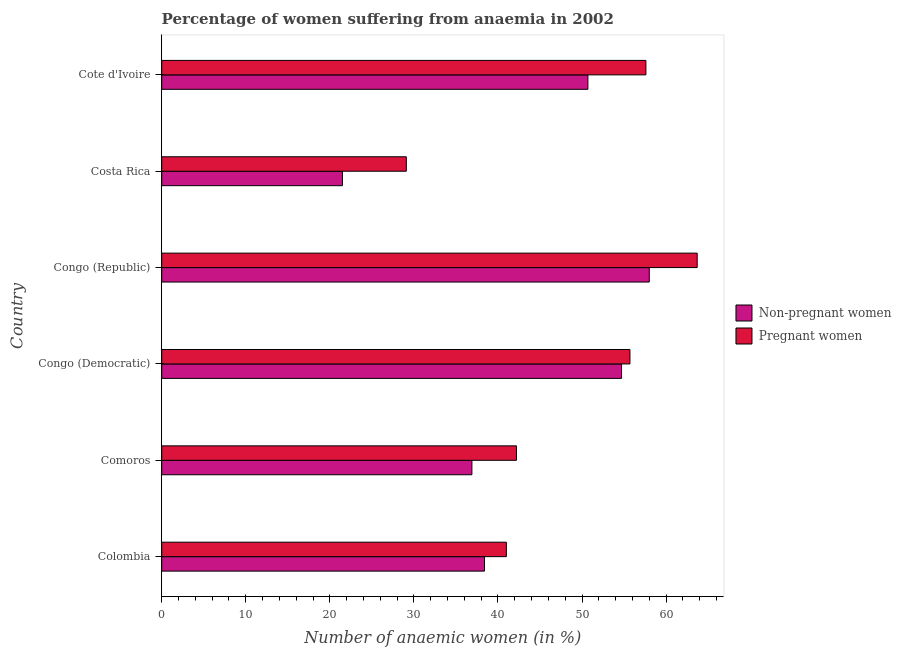How many different coloured bars are there?
Your answer should be compact. 2. Are the number of bars per tick equal to the number of legend labels?
Offer a terse response. Yes. How many bars are there on the 4th tick from the bottom?
Ensure brevity in your answer.  2. What is the label of the 3rd group of bars from the top?
Ensure brevity in your answer.  Congo (Republic). In how many cases, is the number of bars for a given country not equal to the number of legend labels?
Provide a succinct answer. 0. What is the percentage of non-pregnant anaemic women in Congo (Democratic)?
Offer a very short reply. 54.7. Across all countries, what is the maximum percentage of pregnant anaemic women?
Offer a very short reply. 63.7. Across all countries, what is the minimum percentage of pregnant anaemic women?
Provide a succinct answer. 29.1. In which country was the percentage of pregnant anaemic women maximum?
Keep it short and to the point. Congo (Republic). What is the total percentage of non-pregnant anaemic women in the graph?
Provide a short and direct response. 260.2. What is the difference between the percentage of non-pregnant anaemic women in Colombia and that in Congo (Republic)?
Your answer should be compact. -19.6. What is the difference between the percentage of pregnant anaemic women in Costa Rica and the percentage of non-pregnant anaemic women in Congo (Republic)?
Provide a succinct answer. -28.9. What is the average percentage of pregnant anaemic women per country?
Your response must be concise. 48.22. What is the difference between the percentage of pregnant anaemic women and percentage of non-pregnant anaemic women in Cote d'Ivoire?
Your answer should be compact. 6.9. What is the ratio of the percentage of non-pregnant anaemic women in Comoros to that in Congo (Republic)?
Your answer should be very brief. 0.64. Is the difference between the percentage of pregnant anaemic women in Congo (Republic) and Costa Rica greater than the difference between the percentage of non-pregnant anaemic women in Congo (Republic) and Costa Rica?
Offer a very short reply. No. What is the difference between the highest and the lowest percentage of pregnant anaemic women?
Provide a succinct answer. 34.6. Is the sum of the percentage of non-pregnant anaemic women in Colombia and Cote d'Ivoire greater than the maximum percentage of pregnant anaemic women across all countries?
Offer a terse response. Yes. What does the 1st bar from the top in Colombia represents?
Your response must be concise. Pregnant women. What does the 1st bar from the bottom in Congo (Republic) represents?
Offer a terse response. Non-pregnant women. Are all the bars in the graph horizontal?
Your answer should be compact. Yes. What is the difference between two consecutive major ticks on the X-axis?
Offer a terse response. 10. Does the graph contain any zero values?
Your answer should be compact. No. Does the graph contain grids?
Offer a terse response. No. What is the title of the graph?
Your answer should be very brief. Percentage of women suffering from anaemia in 2002. What is the label or title of the X-axis?
Make the answer very short. Number of anaemic women (in %). What is the label or title of the Y-axis?
Your response must be concise. Country. What is the Number of anaemic women (in %) in Non-pregnant women in Colombia?
Keep it short and to the point. 38.4. What is the Number of anaemic women (in %) in Non-pregnant women in Comoros?
Make the answer very short. 36.9. What is the Number of anaemic women (in %) of Pregnant women in Comoros?
Your answer should be compact. 42.2. What is the Number of anaemic women (in %) in Non-pregnant women in Congo (Democratic)?
Keep it short and to the point. 54.7. What is the Number of anaemic women (in %) in Pregnant women in Congo (Democratic)?
Keep it short and to the point. 55.7. What is the Number of anaemic women (in %) of Non-pregnant women in Congo (Republic)?
Your answer should be very brief. 58. What is the Number of anaemic women (in %) in Pregnant women in Congo (Republic)?
Your answer should be compact. 63.7. What is the Number of anaemic women (in %) in Non-pregnant women in Costa Rica?
Offer a terse response. 21.5. What is the Number of anaemic women (in %) of Pregnant women in Costa Rica?
Offer a very short reply. 29.1. What is the Number of anaemic women (in %) of Non-pregnant women in Cote d'Ivoire?
Ensure brevity in your answer.  50.7. What is the Number of anaemic women (in %) of Pregnant women in Cote d'Ivoire?
Your response must be concise. 57.6. Across all countries, what is the maximum Number of anaemic women (in %) in Pregnant women?
Your answer should be very brief. 63.7. Across all countries, what is the minimum Number of anaemic women (in %) in Non-pregnant women?
Provide a short and direct response. 21.5. Across all countries, what is the minimum Number of anaemic women (in %) in Pregnant women?
Offer a terse response. 29.1. What is the total Number of anaemic women (in %) of Non-pregnant women in the graph?
Your response must be concise. 260.2. What is the total Number of anaemic women (in %) in Pregnant women in the graph?
Keep it short and to the point. 289.3. What is the difference between the Number of anaemic women (in %) of Non-pregnant women in Colombia and that in Comoros?
Make the answer very short. 1.5. What is the difference between the Number of anaemic women (in %) of Pregnant women in Colombia and that in Comoros?
Keep it short and to the point. -1.2. What is the difference between the Number of anaemic women (in %) in Non-pregnant women in Colombia and that in Congo (Democratic)?
Your answer should be compact. -16.3. What is the difference between the Number of anaemic women (in %) of Pregnant women in Colombia and that in Congo (Democratic)?
Offer a very short reply. -14.7. What is the difference between the Number of anaemic women (in %) in Non-pregnant women in Colombia and that in Congo (Republic)?
Make the answer very short. -19.6. What is the difference between the Number of anaemic women (in %) in Pregnant women in Colombia and that in Congo (Republic)?
Offer a very short reply. -22.7. What is the difference between the Number of anaemic women (in %) of Non-pregnant women in Colombia and that in Cote d'Ivoire?
Your answer should be very brief. -12.3. What is the difference between the Number of anaemic women (in %) in Pregnant women in Colombia and that in Cote d'Ivoire?
Offer a terse response. -16.6. What is the difference between the Number of anaemic women (in %) in Non-pregnant women in Comoros and that in Congo (Democratic)?
Ensure brevity in your answer.  -17.8. What is the difference between the Number of anaemic women (in %) of Non-pregnant women in Comoros and that in Congo (Republic)?
Keep it short and to the point. -21.1. What is the difference between the Number of anaemic women (in %) of Pregnant women in Comoros and that in Congo (Republic)?
Your answer should be compact. -21.5. What is the difference between the Number of anaemic women (in %) in Non-pregnant women in Comoros and that in Cote d'Ivoire?
Give a very brief answer. -13.8. What is the difference between the Number of anaemic women (in %) of Pregnant women in Comoros and that in Cote d'Ivoire?
Offer a very short reply. -15.4. What is the difference between the Number of anaemic women (in %) in Non-pregnant women in Congo (Democratic) and that in Congo (Republic)?
Offer a terse response. -3.3. What is the difference between the Number of anaemic women (in %) of Pregnant women in Congo (Democratic) and that in Congo (Republic)?
Make the answer very short. -8. What is the difference between the Number of anaemic women (in %) of Non-pregnant women in Congo (Democratic) and that in Costa Rica?
Your answer should be compact. 33.2. What is the difference between the Number of anaemic women (in %) in Pregnant women in Congo (Democratic) and that in Costa Rica?
Keep it short and to the point. 26.6. What is the difference between the Number of anaemic women (in %) in Non-pregnant women in Congo (Republic) and that in Costa Rica?
Give a very brief answer. 36.5. What is the difference between the Number of anaemic women (in %) in Pregnant women in Congo (Republic) and that in Costa Rica?
Ensure brevity in your answer.  34.6. What is the difference between the Number of anaemic women (in %) of Non-pregnant women in Congo (Republic) and that in Cote d'Ivoire?
Make the answer very short. 7.3. What is the difference between the Number of anaemic women (in %) of Non-pregnant women in Costa Rica and that in Cote d'Ivoire?
Your response must be concise. -29.2. What is the difference between the Number of anaemic women (in %) in Pregnant women in Costa Rica and that in Cote d'Ivoire?
Your response must be concise. -28.5. What is the difference between the Number of anaemic women (in %) in Non-pregnant women in Colombia and the Number of anaemic women (in %) in Pregnant women in Comoros?
Offer a terse response. -3.8. What is the difference between the Number of anaemic women (in %) in Non-pregnant women in Colombia and the Number of anaemic women (in %) in Pregnant women in Congo (Democratic)?
Ensure brevity in your answer.  -17.3. What is the difference between the Number of anaemic women (in %) of Non-pregnant women in Colombia and the Number of anaemic women (in %) of Pregnant women in Congo (Republic)?
Give a very brief answer. -25.3. What is the difference between the Number of anaemic women (in %) of Non-pregnant women in Colombia and the Number of anaemic women (in %) of Pregnant women in Costa Rica?
Your answer should be compact. 9.3. What is the difference between the Number of anaemic women (in %) of Non-pregnant women in Colombia and the Number of anaemic women (in %) of Pregnant women in Cote d'Ivoire?
Offer a terse response. -19.2. What is the difference between the Number of anaemic women (in %) of Non-pregnant women in Comoros and the Number of anaemic women (in %) of Pregnant women in Congo (Democratic)?
Keep it short and to the point. -18.8. What is the difference between the Number of anaemic women (in %) in Non-pregnant women in Comoros and the Number of anaemic women (in %) in Pregnant women in Congo (Republic)?
Provide a short and direct response. -26.8. What is the difference between the Number of anaemic women (in %) of Non-pregnant women in Comoros and the Number of anaemic women (in %) of Pregnant women in Cote d'Ivoire?
Ensure brevity in your answer.  -20.7. What is the difference between the Number of anaemic women (in %) of Non-pregnant women in Congo (Democratic) and the Number of anaemic women (in %) of Pregnant women in Congo (Republic)?
Your answer should be compact. -9. What is the difference between the Number of anaemic women (in %) of Non-pregnant women in Congo (Democratic) and the Number of anaemic women (in %) of Pregnant women in Costa Rica?
Offer a very short reply. 25.6. What is the difference between the Number of anaemic women (in %) of Non-pregnant women in Congo (Democratic) and the Number of anaemic women (in %) of Pregnant women in Cote d'Ivoire?
Your answer should be compact. -2.9. What is the difference between the Number of anaemic women (in %) of Non-pregnant women in Congo (Republic) and the Number of anaemic women (in %) of Pregnant women in Costa Rica?
Your answer should be compact. 28.9. What is the difference between the Number of anaemic women (in %) in Non-pregnant women in Congo (Republic) and the Number of anaemic women (in %) in Pregnant women in Cote d'Ivoire?
Offer a very short reply. 0.4. What is the difference between the Number of anaemic women (in %) in Non-pregnant women in Costa Rica and the Number of anaemic women (in %) in Pregnant women in Cote d'Ivoire?
Your answer should be very brief. -36.1. What is the average Number of anaemic women (in %) in Non-pregnant women per country?
Ensure brevity in your answer.  43.37. What is the average Number of anaemic women (in %) in Pregnant women per country?
Provide a short and direct response. 48.22. What is the difference between the Number of anaemic women (in %) in Non-pregnant women and Number of anaemic women (in %) in Pregnant women in Comoros?
Make the answer very short. -5.3. What is the difference between the Number of anaemic women (in %) of Non-pregnant women and Number of anaemic women (in %) of Pregnant women in Congo (Democratic)?
Give a very brief answer. -1. What is the difference between the Number of anaemic women (in %) in Non-pregnant women and Number of anaemic women (in %) in Pregnant women in Congo (Republic)?
Give a very brief answer. -5.7. What is the ratio of the Number of anaemic women (in %) in Non-pregnant women in Colombia to that in Comoros?
Offer a very short reply. 1.04. What is the ratio of the Number of anaemic women (in %) in Pregnant women in Colombia to that in Comoros?
Your answer should be compact. 0.97. What is the ratio of the Number of anaemic women (in %) of Non-pregnant women in Colombia to that in Congo (Democratic)?
Offer a very short reply. 0.7. What is the ratio of the Number of anaemic women (in %) in Pregnant women in Colombia to that in Congo (Democratic)?
Your answer should be compact. 0.74. What is the ratio of the Number of anaemic women (in %) of Non-pregnant women in Colombia to that in Congo (Republic)?
Provide a short and direct response. 0.66. What is the ratio of the Number of anaemic women (in %) of Pregnant women in Colombia to that in Congo (Republic)?
Offer a very short reply. 0.64. What is the ratio of the Number of anaemic women (in %) in Non-pregnant women in Colombia to that in Costa Rica?
Ensure brevity in your answer.  1.79. What is the ratio of the Number of anaemic women (in %) of Pregnant women in Colombia to that in Costa Rica?
Offer a terse response. 1.41. What is the ratio of the Number of anaemic women (in %) of Non-pregnant women in Colombia to that in Cote d'Ivoire?
Your response must be concise. 0.76. What is the ratio of the Number of anaemic women (in %) of Pregnant women in Colombia to that in Cote d'Ivoire?
Keep it short and to the point. 0.71. What is the ratio of the Number of anaemic women (in %) in Non-pregnant women in Comoros to that in Congo (Democratic)?
Your answer should be very brief. 0.67. What is the ratio of the Number of anaemic women (in %) of Pregnant women in Comoros to that in Congo (Democratic)?
Keep it short and to the point. 0.76. What is the ratio of the Number of anaemic women (in %) of Non-pregnant women in Comoros to that in Congo (Republic)?
Provide a short and direct response. 0.64. What is the ratio of the Number of anaemic women (in %) in Pregnant women in Comoros to that in Congo (Republic)?
Offer a terse response. 0.66. What is the ratio of the Number of anaemic women (in %) in Non-pregnant women in Comoros to that in Costa Rica?
Offer a very short reply. 1.72. What is the ratio of the Number of anaemic women (in %) in Pregnant women in Comoros to that in Costa Rica?
Provide a succinct answer. 1.45. What is the ratio of the Number of anaemic women (in %) in Non-pregnant women in Comoros to that in Cote d'Ivoire?
Provide a short and direct response. 0.73. What is the ratio of the Number of anaemic women (in %) of Pregnant women in Comoros to that in Cote d'Ivoire?
Provide a succinct answer. 0.73. What is the ratio of the Number of anaemic women (in %) in Non-pregnant women in Congo (Democratic) to that in Congo (Republic)?
Provide a short and direct response. 0.94. What is the ratio of the Number of anaemic women (in %) in Pregnant women in Congo (Democratic) to that in Congo (Republic)?
Make the answer very short. 0.87. What is the ratio of the Number of anaemic women (in %) in Non-pregnant women in Congo (Democratic) to that in Costa Rica?
Your answer should be very brief. 2.54. What is the ratio of the Number of anaemic women (in %) of Pregnant women in Congo (Democratic) to that in Costa Rica?
Offer a very short reply. 1.91. What is the ratio of the Number of anaemic women (in %) in Non-pregnant women in Congo (Democratic) to that in Cote d'Ivoire?
Your response must be concise. 1.08. What is the ratio of the Number of anaemic women (in %) in Non-pregnant women in Congo (Republic) to that in Costa Rica?
Offer a very short reply. 2.7. What is the ratio of the Number of anaemic women (in %) of Pregnant women in Congo (Republic) to that in Costa Rica?
Your answer should be very brief. 2.19. What is the ratio of the Number of anaemic women (in %) of Non-pregnant women in Congo (Republic) to that in Cote d'Ivoire?
Your answer should be compact. 1.14. What is the ratio of the Number of anaemic women (in %) in Pregnant women in Congo (Republic) to that in Cote d'Ivoire?
Provide a succinct answer. 1.11. What is the ratio of the Number of anaemic women (in %) of Non-pregnant women in Costa Rica to that in Cote d'Ivoire?
Ensure brevity in your answer.  0.42. What is the ratio of the Number of anaemic women (in %) of Pregnant women in Costa Rica to that in Cote d'Ivoire?
Give a very brief answer. 0.51. What is the difference between the highest and the second highest Number of anaemic women (in %) in Pregnant women?
Provide a short and direct response. 6.1. What is the difference between the highest and the lowest Number of anaemic women (in %) in Non-pregnant women?
Ensure brevity in your answer.  36.5. What is the difference between the highest and the lowest Number of anaemic women (in %) of Pregnant women?
Give a very brief answer. 34.6. 